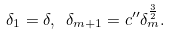<formula> <loc_0><loc_0><loc_500><loc_500>\delta _ { 1 } = \delta , \ \delta _ { m + 1 } = c ^ { \prime \prime } \delta _ { m } ^ { \frac { 3 } { 2 } } .</formula> 